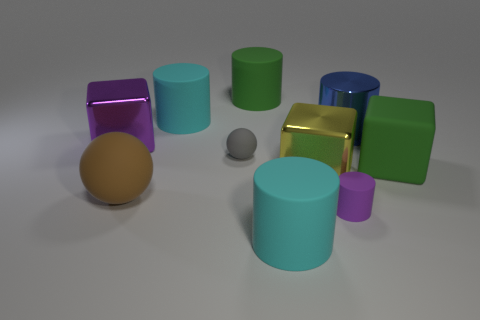Subtract 1 cylinders. How many cylinders are left? 4 Subtract all green cylinders. How many cylinders are left? 4 Subtract all big green rubber cylinders. How many cylinders are left? 4 Subtract all gray cylinders. Subtract all red blocks. How many cylinders are left? 5 Subtract all balls. How many objects are left? 8 Add 1 brown rubber balls. How many brown rubber balls are left? 2 Add 4 big cylinders. How many big cylinders exist? 8 Subtract 1 gray balls. How many objects are left? 9 Subtract all cubes. Subtract all purple matte cylinders. How many objects are left? 6 